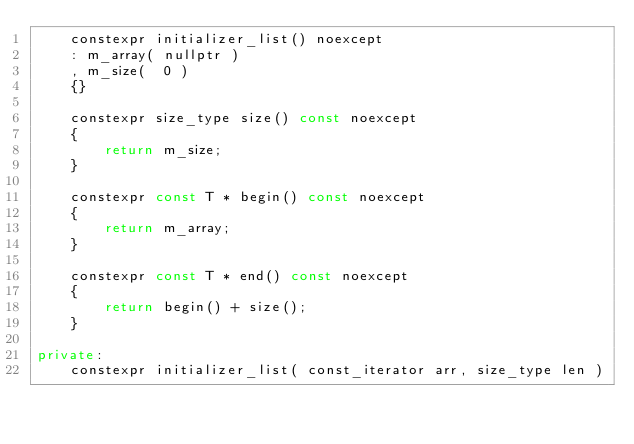Convert code to text. <code><loc_0><loc_0><loc_500><loc_500><_C++_>    constexpr initializer_list() noexcept
    : m_array( nullptr )
    , m_size(  0 )
    {}

    constexpr size_type size() const noexcept
    {
        return m_size;
    }

    constexpr const T * begin() const noexcept
    {
        return m_array;
    }

    constexpr const T * end() const noexcept
    {
        return begin() + size();
    }

private:
    constexpr initializer_list( const_iterator arr, size_type len )</code> 